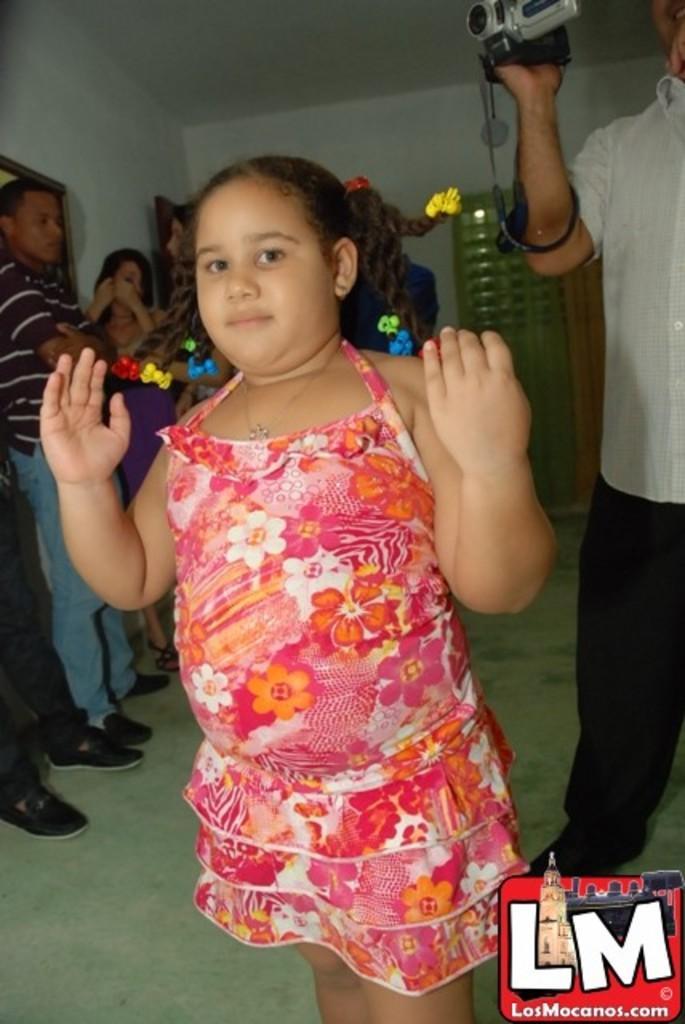In one or two sentences, can you explain what this image depicts? In this image I can see a group of people are standing on the floor and a logo at the bottom. In the background I can see a wall and a door. This image is taken in a hall. 